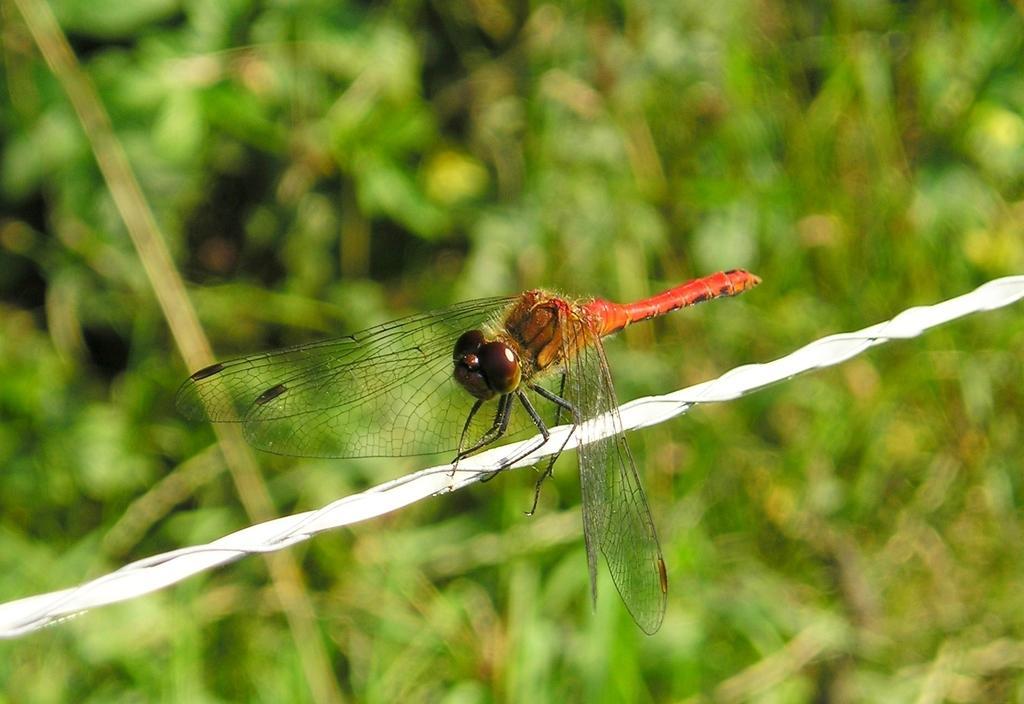Please provide a concise description of this image. Here we can see an insect on white rope. Background it is blur. 